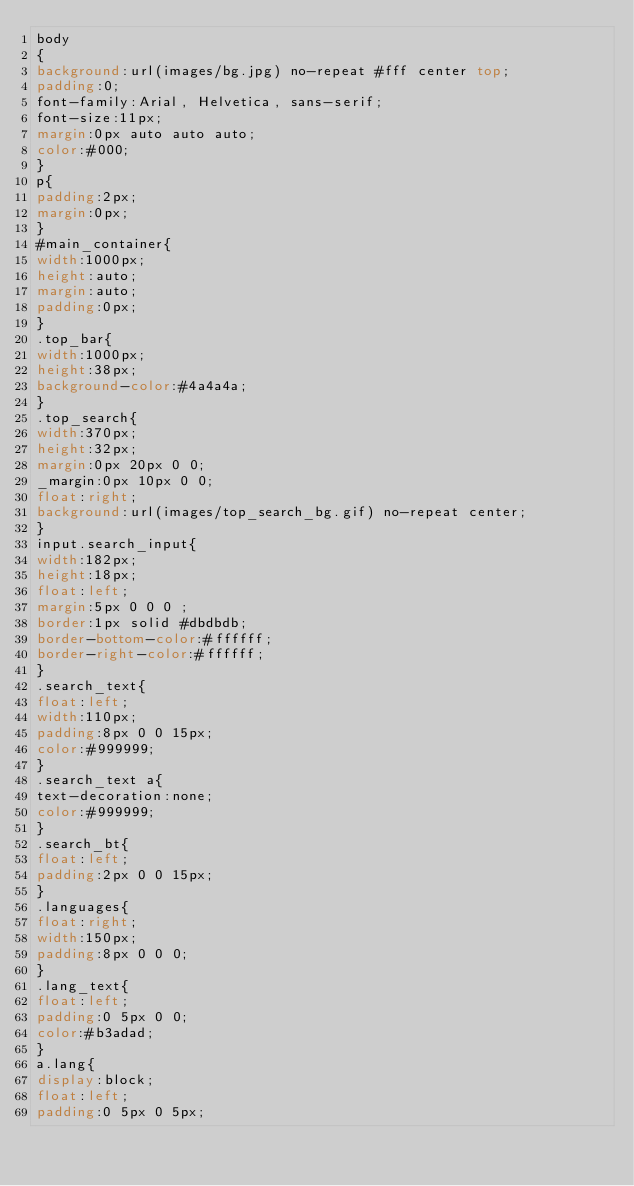<code> <loc_0><loc_0><loc_500><loc_500><_CSS_>body
{
background:url(images/bg.jpg) no-repeat #fff center top;
padding:0;
font-family:Arial, Helvetica, sans-serif;
font-size:11px;
margin:0px auto auto auto;
color:#000;
}
p{
padding:2px;
margin:0px;
}
#main_container{
width:1000px;
height:auto;
margin:auto;
padding:0px;
}
.top_bar{
width:1000px;
height:38px;
background-color:#4a4a4a;
}
.top_search{
width:370px;
height:32px;
margin:0px 20px 0 0;
_margin:0px 10px 0 0;
float:right;
background:url(images/top_search_bg.gif) no-repeat center;
}
input.search_input{
width:182px;
height:18px;
float:left;
margin:5px 0 0 0 ;
border:1px solid #dbdbdb;
border-bottom-color:#ffffff;
border-right-color:#ffffff;
}
.search_text{
float:left;
width:110px;
padding:8px 0 0 15px;
color:#999999;
}
.search_text a{
text-decoration:none;
color:#999999;
}
.search_bt{
float:left;
padding:2px 0 0 15px;
}
.languages{
float:right;
width:150px;
padding:8px 0 0 0;
}
.lang_text{
float:left;
padding:0 5px 0 0;
color:#b3adad;
}
a.lang{
display:block;
float:left;
padding:0 5px 0 5px;</code> 